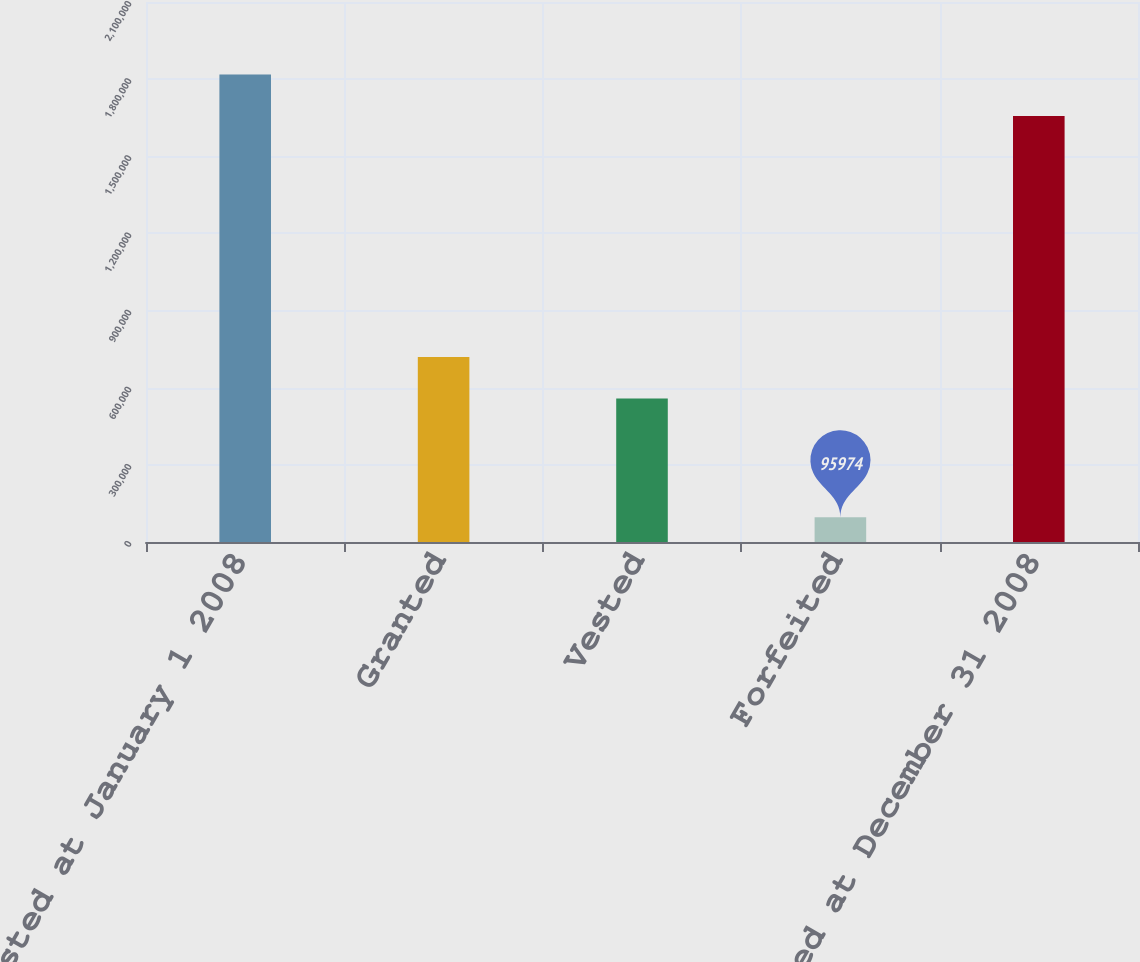Convert chart. <chart><loc_0><loc_0><loc_500><loc_500><bar_chart><fcel>Nonvested at January 1 2008<fcel>Granted<fcel>Vested<fcel>Forfeited<fcel>Nonvested at December 31 2008<nl><fcel>1.8177e+06<fcel>719147<fcel>558281<fcel>95974<fcel>1.65683e+06<nl></chart> 